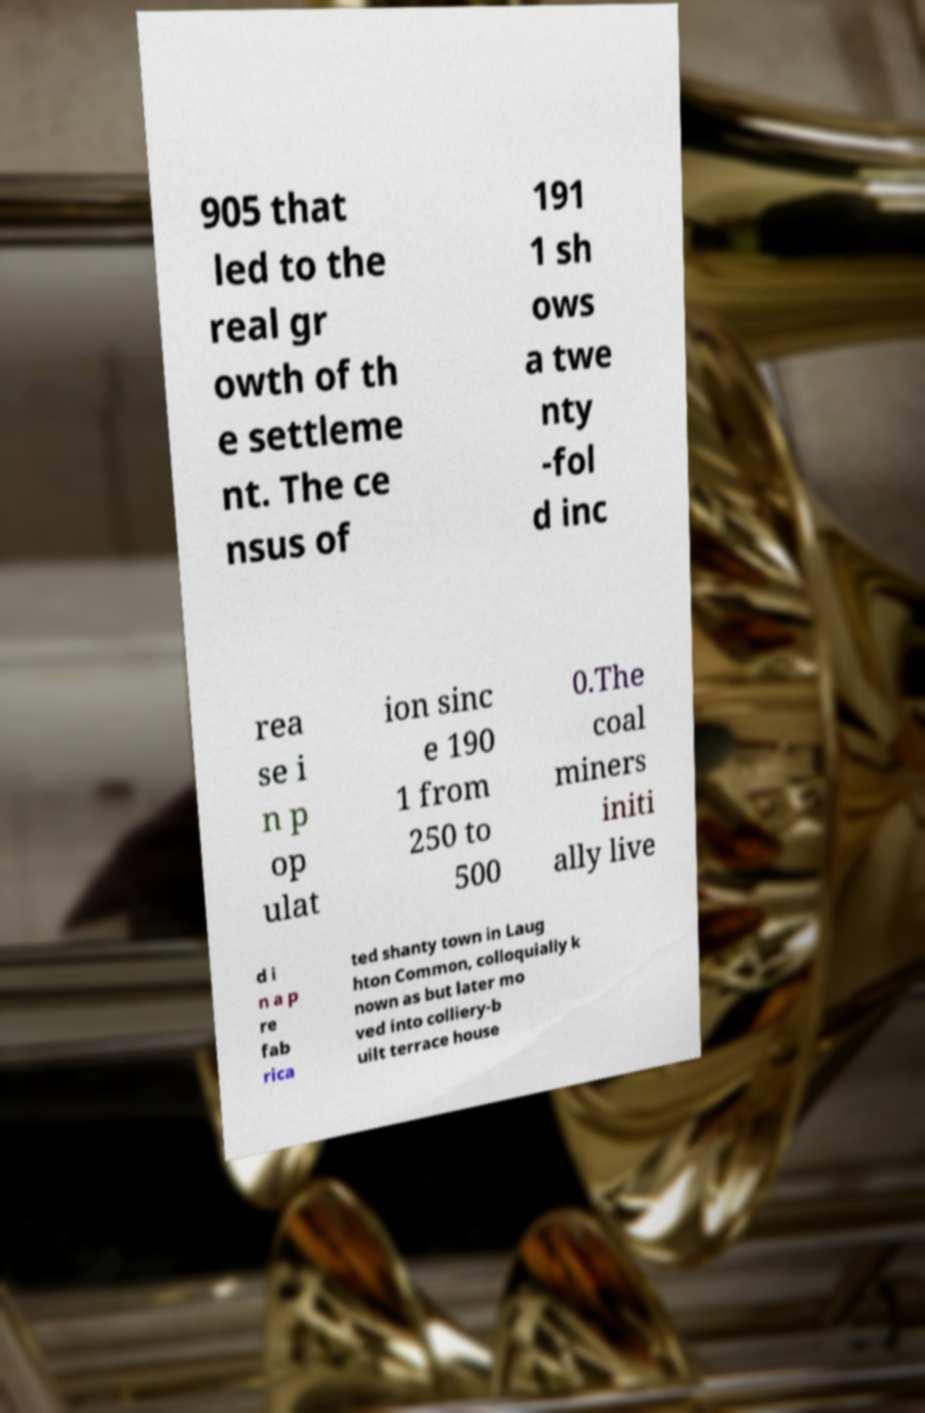Can you read and provide the text displayed in the image?This photo seems to have some interesting text. Can you extract and type it out for me? 905 that led to the real gr owth of th e settleme nt. The ce nsus of 191 1 sh ows a twe nty -fol d inc rea se i n p op ulat ion sinc e 190 1 from 250 to 500 0.The coal miners initi ally live d i n a p re fab rica ted shanty town in Laug hton Common, colloquially k nown as but later mo ved into colliery-b uilt terrace house 